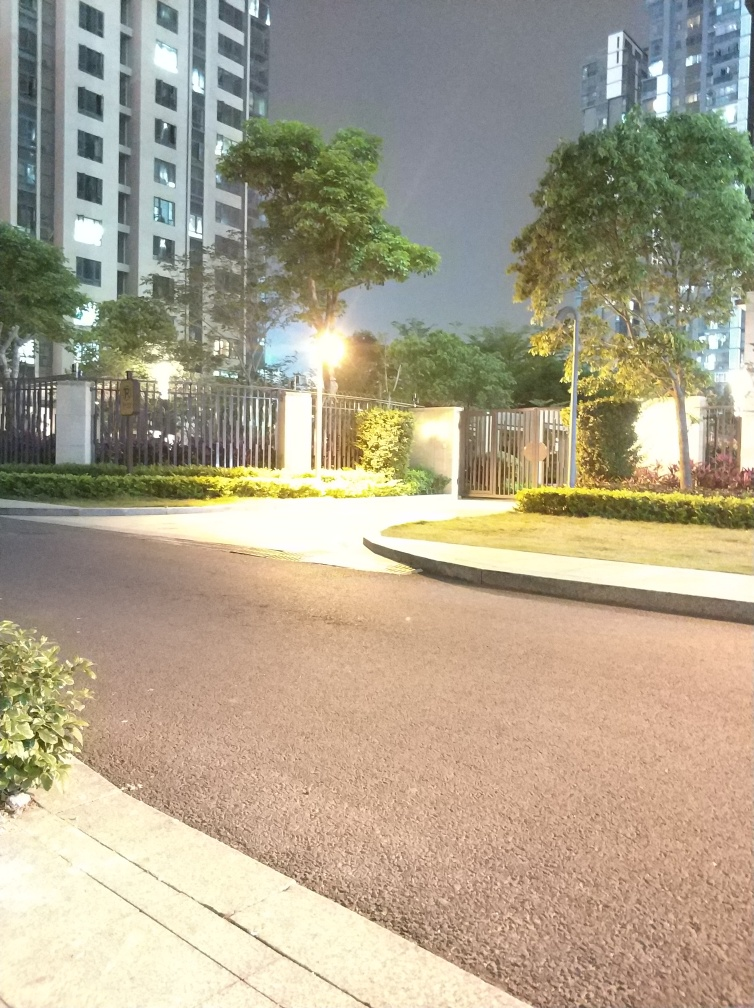Are there any visible quality issues in the image? While the image appears relatively clear, there is overexposure due to the bright light sources, which causes a loss of detail in those areas. Additionally, the darkness of the surroundings makes it difficult to discern certain features, and the high contrast creates a stark appearance. It is thus fair to say that some quality issues are present. 